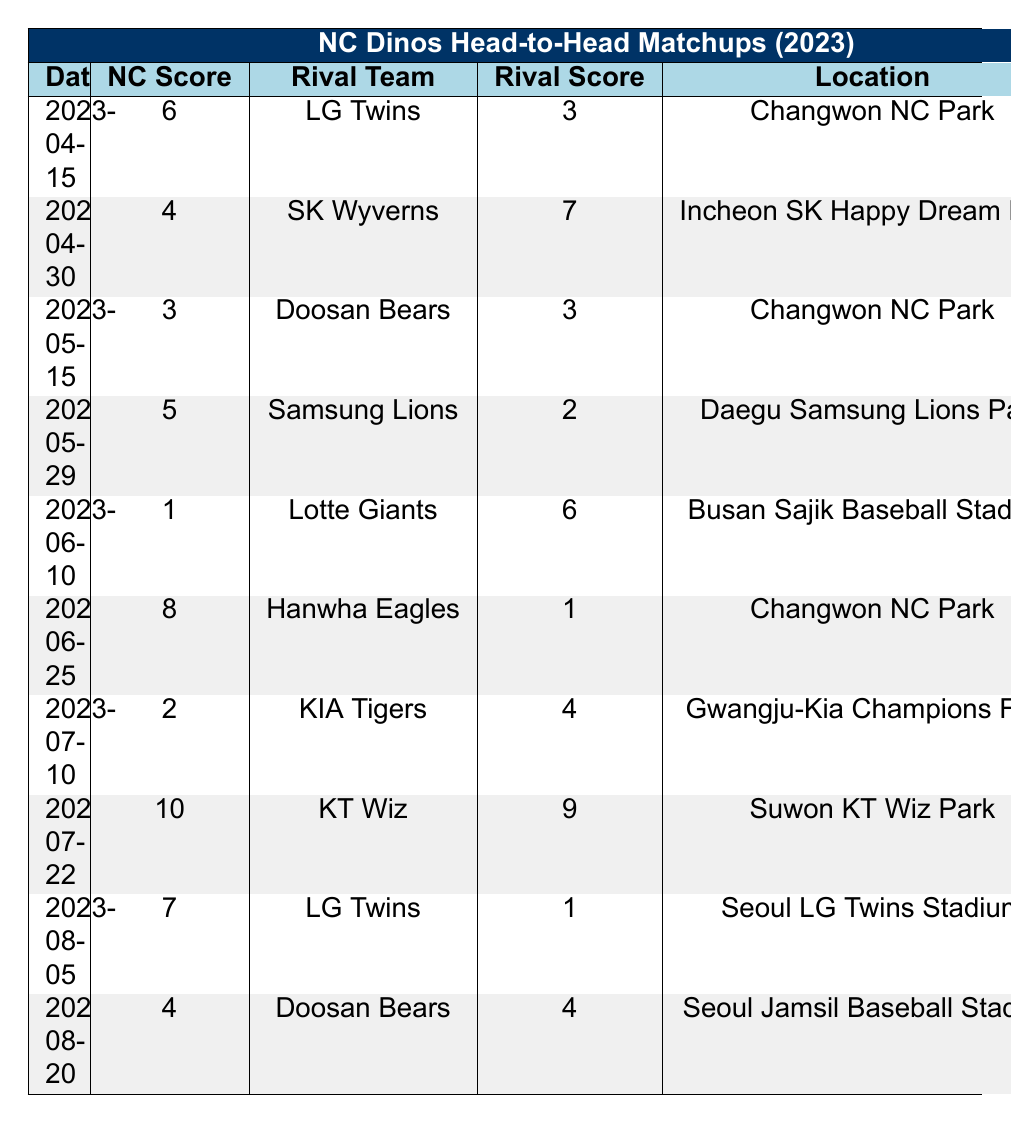What was the NC Dinos score in their game against the LG Twins on April 15, 2023? Looking at the table, on April 15, 2023, the NC Dinos scored 6 points in their matchup against the LG Twins.
Answer: 6 Who won the game between the NC Dinos and SK Wyverns on April 30, 2023? The table indicates that in the game on April 30, 2023, the SK Wyverns won, as their score (7) was higher than the NC Dinos' score (4).
Answer: SK Wyverns Was there a draw match between the NC Dinos and Doosan Bears in 2023? Yes, according to the table, there were two matches against the Doosan Bears, and one match on May 15 ended in a draw with both teams scoring 3 points.
Answer: Yes What is the total number of games the NC Dinos played against the LG Twins in 2023? The table shows two matches against the LG Twins: one on April 15 and another on August 5. Thus, the total number is 2.
Answer: 2 Which rival team did the NC Dinos score the highest against in 2023, and what was the score? Reviewing the table, the NC Dinos scored their highest against the KT Wiz on July 22, with a score of 10.
Answer: KT Wiz, 10 On which date did the NC Dinos have their lowest score in 2023, and what was that score? Looking at the table, the NC Dinos had their lowest score on June 10, 2023, where they scored only 1 point against the Lotte Giants.
Answer: June 10, 1 How many games did the NC Dinos win in head-to-head matchups recorded in the table? By examining the results, the NC Dinos won 4 games: against LG Twins (April 15), Samsung Lions (May 29), Hanwha Eagles (June 25), and KT Wiz (July 22).
Answer: 4 Did the NC Dinos ever outscore their opponents by more than 5 points? Yes, when they played against the Hanwha Eagles on June 25, 2023, the NC Dinos scored 8, while the Eagles scored only 1, resulting in a 7-point difference.
Answer: Yes Overall, what was the NC Dinos' average score in their head-to-head matchups? To calculate the average, sum the NC Dinos' scores (6 + 4 + 3 + 5 + 1 + 8 + 2 + 10 + 7 + 4) = 46. Then divide by the total number of games (10): 46/10 = 4.6.
Answer: 4.6 